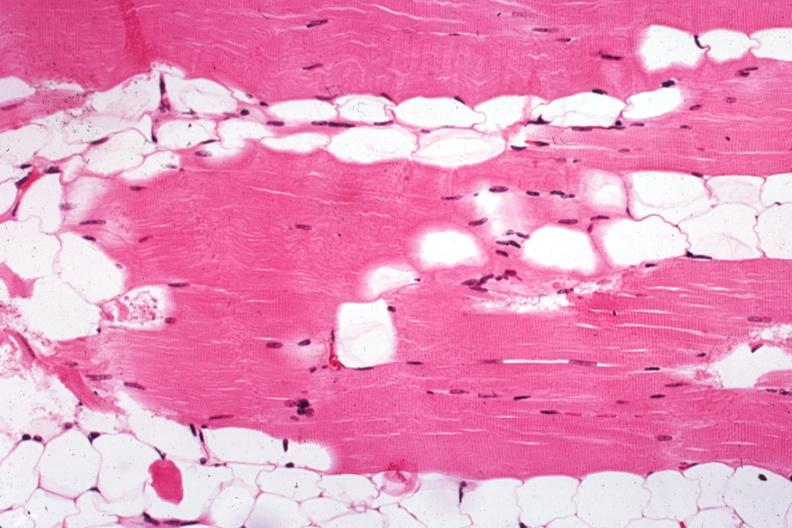s muscle present?
Answer the question using a single word or phrase. Yes 